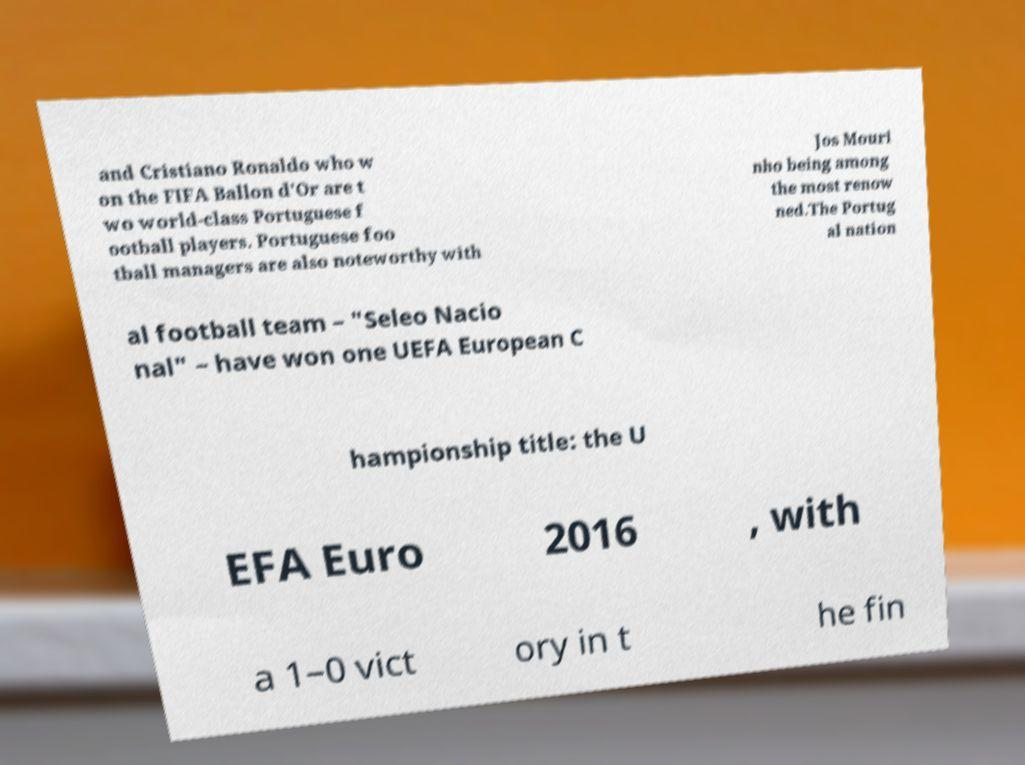Could you assist in decoding the text presented in this image and type it out clearly? and Cristiano Ronaldo who w on the FIFA Ballon d'Or are t wo world-class Portuguese f ootball players. Portuguese foo tball managers are also noteworthy with Jos Mouri nho being among the most renow ned.The Portug al nation al football team – "Seleo Nacio nal" – have won one UEFA European C hampionship title: the U EFA Euro 2016 , with a 1–0 vict ory in t he fin 